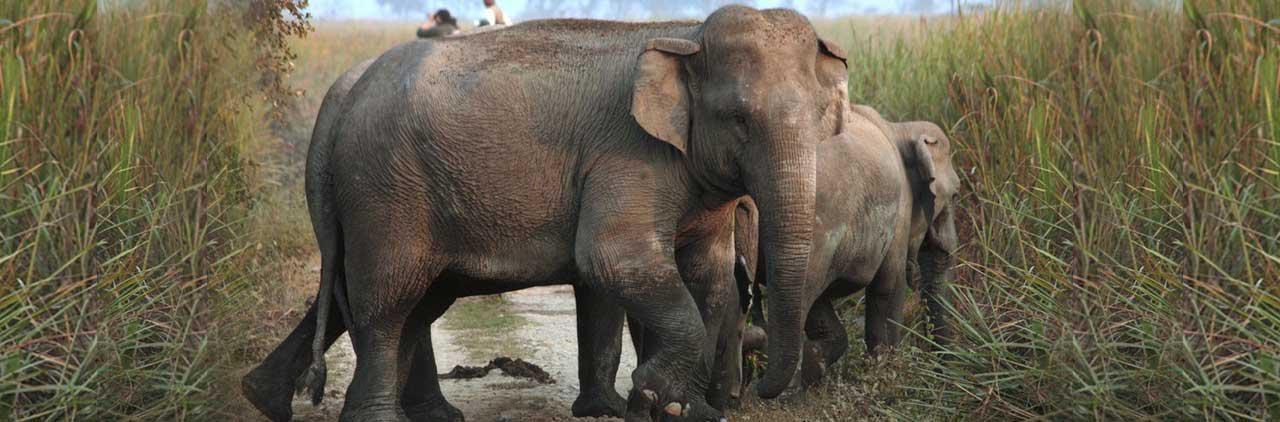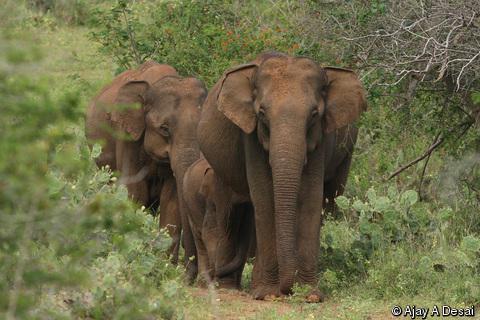The first image is the image on the left, the second image is the image on the right. Examine the images to the left and right. Is the description "In one image, and elephant with tusks has its ears fanned out their full width." accurate? Answer yes or no. No. 